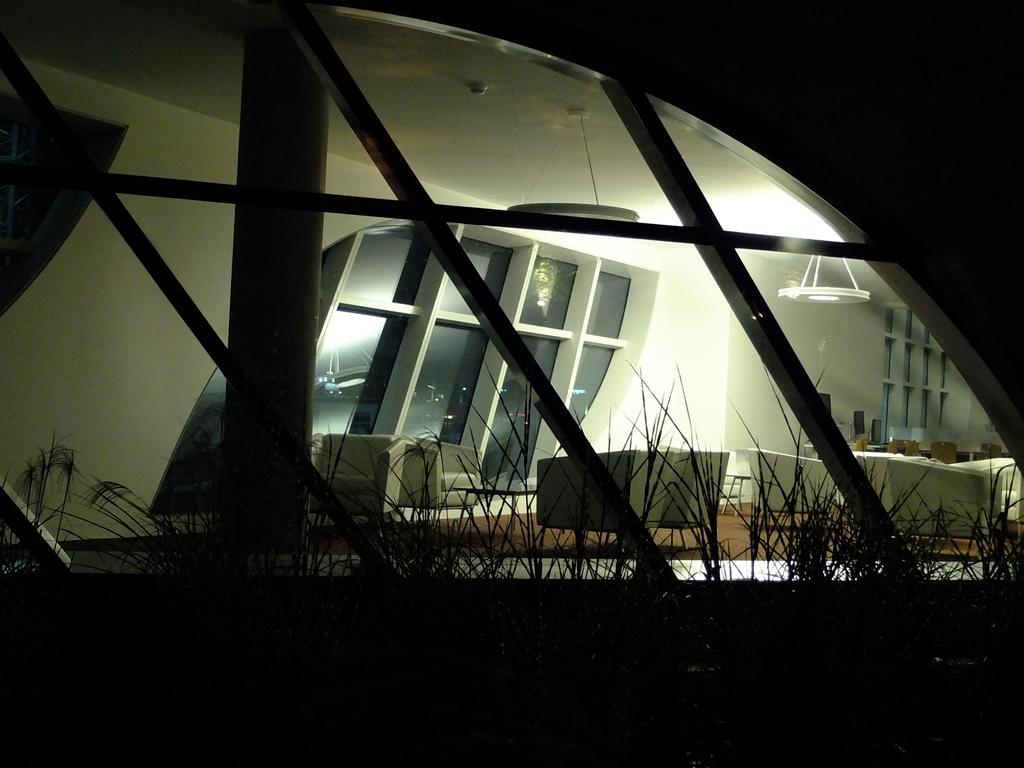What type of furniture is present in the image? There are chairs and a couch in the image. Where are the chairs and couch located? The chairs and couch are on the floor in the image. What can be seen through the windows in the image? There are no specific details about what can be seen through the windows, but we know that there are windows present. What other objects can be seen in the image? There are plants and lights on the roof in the image. How many ladybugs are crawling on the couch in the image? There are no ladybugs present in the image; only chairs, a couch, windows, plants, and lights on the roof can be seen. 